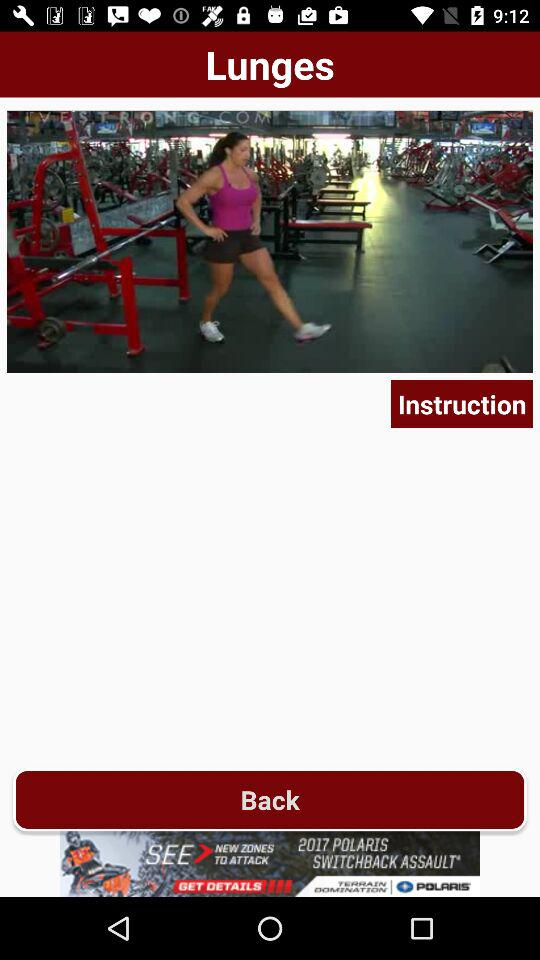What is the name of the exercise? The name of the exercise is lunges. 